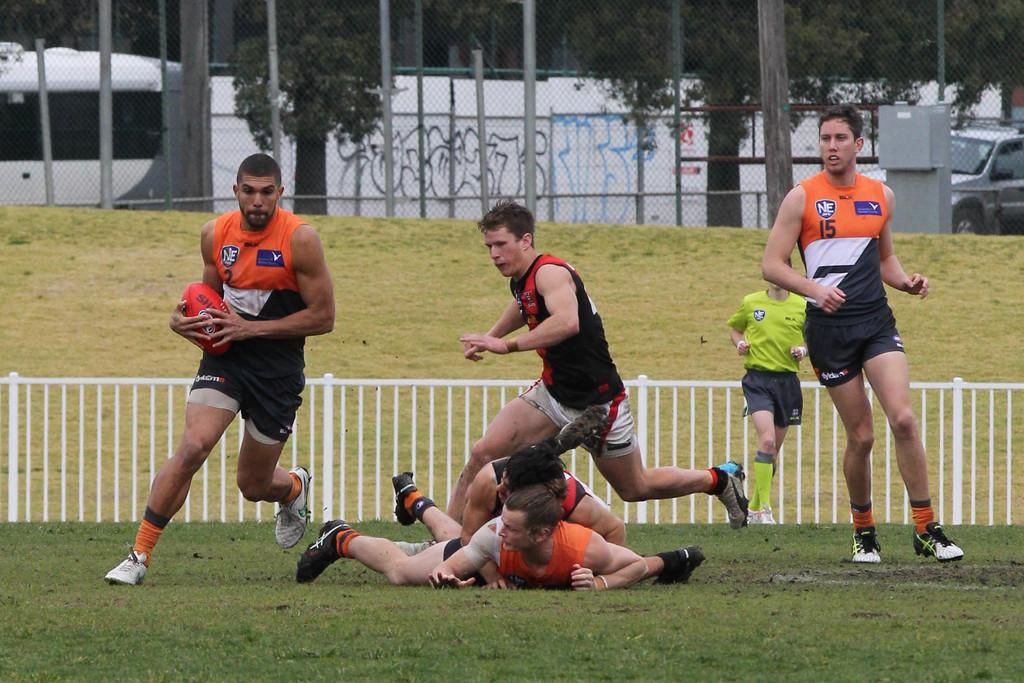<image>
Relay a brief, clear account of the picture shown. runners with one of them wearing the number 15 